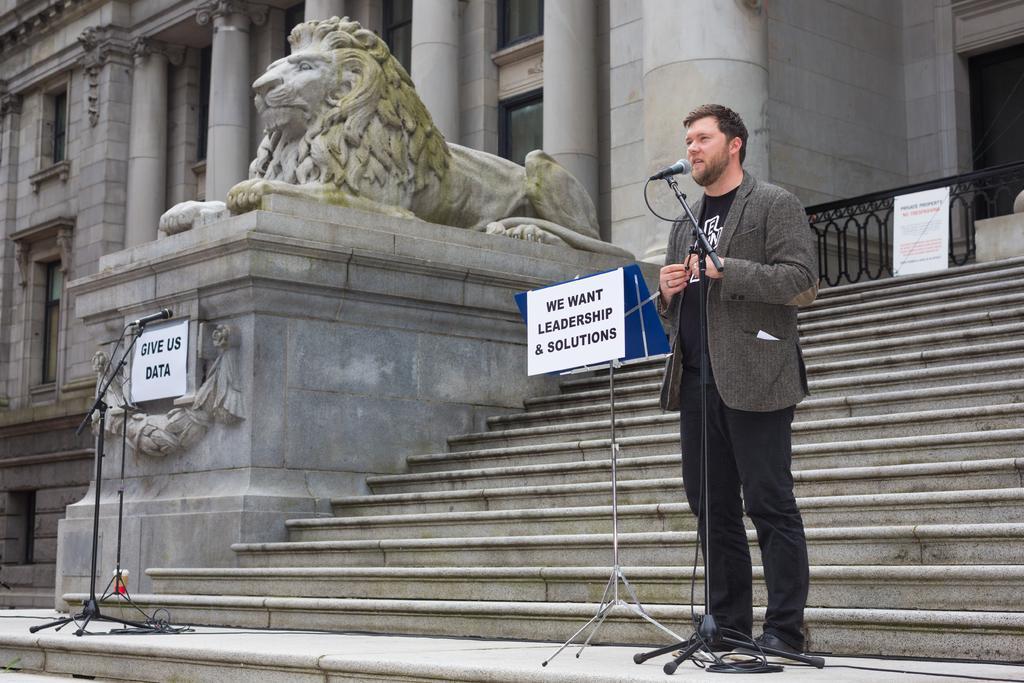Could you give a brief overview of what you see in this image? In this picture, we see a man in the blazer is standing. In front of him, we see a microphone stand. I think he is talking on the microphone. We see a stand and a board in white color with some text written on it. Behind him, we see the staircase. In the middle, we see the statue of a lion. Beside that, we see a microphone stand and a board in white color with some text written on it. On the right side, we see the railing and a board in white color with some text written on it. In the background, we see a building and the pillars. 